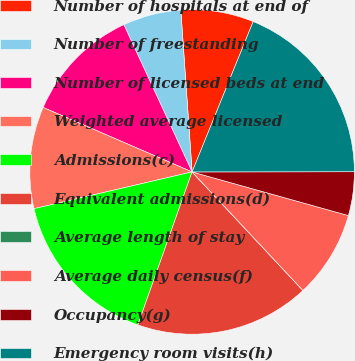Convert chart. <chart><loc_0><loc_0><loc_500><loc_500><pie_chart><fcel>Number of hospitals at end of<fcel>Number of freestanding<fcel>Number of licensed beds at end<fcel>Weighted average licensed<fcel>Admissions(c)<fcel>Equivalent admissions(d)<fcel>Average length of stay<fcel>Average daily census(f)<fcel>Occupancy(g)<fcel>Emergency room visits(h)<nl><fcel>7.25%<fcel>5.8%<fcel>11.59%<fcel>10.14%<fcel>15.94%<fcel>17.39%<fcel>0.0%<fcel>8.7%<fcel>4.35%<fcel>18.84%<nl></chart> 